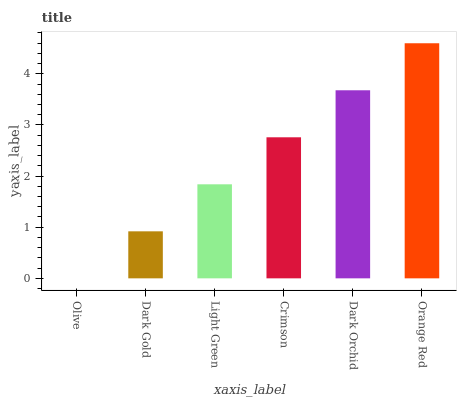Is Olive the minimum?
Answer yes or no. Yes. Is Orange Red the maximum?
Answer yes or no. Yes. Is Dark Gold the minimum?
Answer yes or no. No. Is Dark Gold the maximum?
Answer yes or no. No. Is Dark Gold greater than Olive?
Answer yes or no. Yes. Is Olive less than Dark Gold?
Answer yes or no. Yes. Is Olive greater than Dark Gold?
Answer yes or no. No. Is Dark Gold less than Olive?
Answer yes or no. No. Is Crimson the high median?
Answer yes or no. Yes. Is Light Green the low median?
Answer yes or no. Yes. Is Dark Orchid the high median?
Answer yes or no. No. Is Dark Gold the low median?
Answer yes or no. No. 